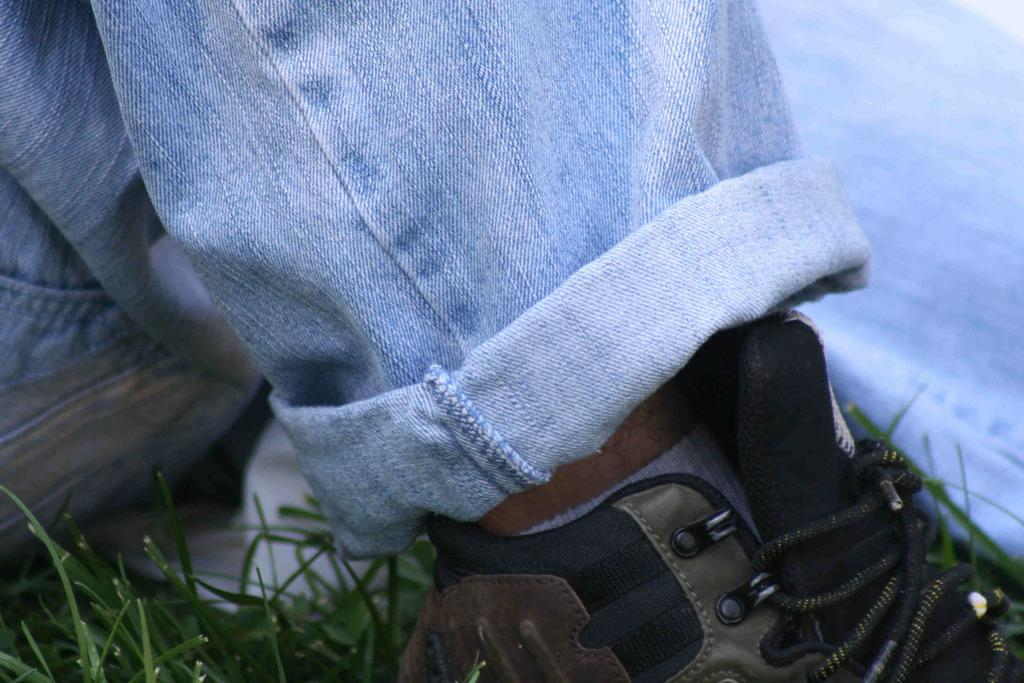What part of a person can be seen in the image? There are legs of a person in the image. What type of surface are the legs on? The legs are on the grass. What color is the paint on the mom's shirt in the image? There is no mom or paint present in the image; it only shows legs on the grass. 